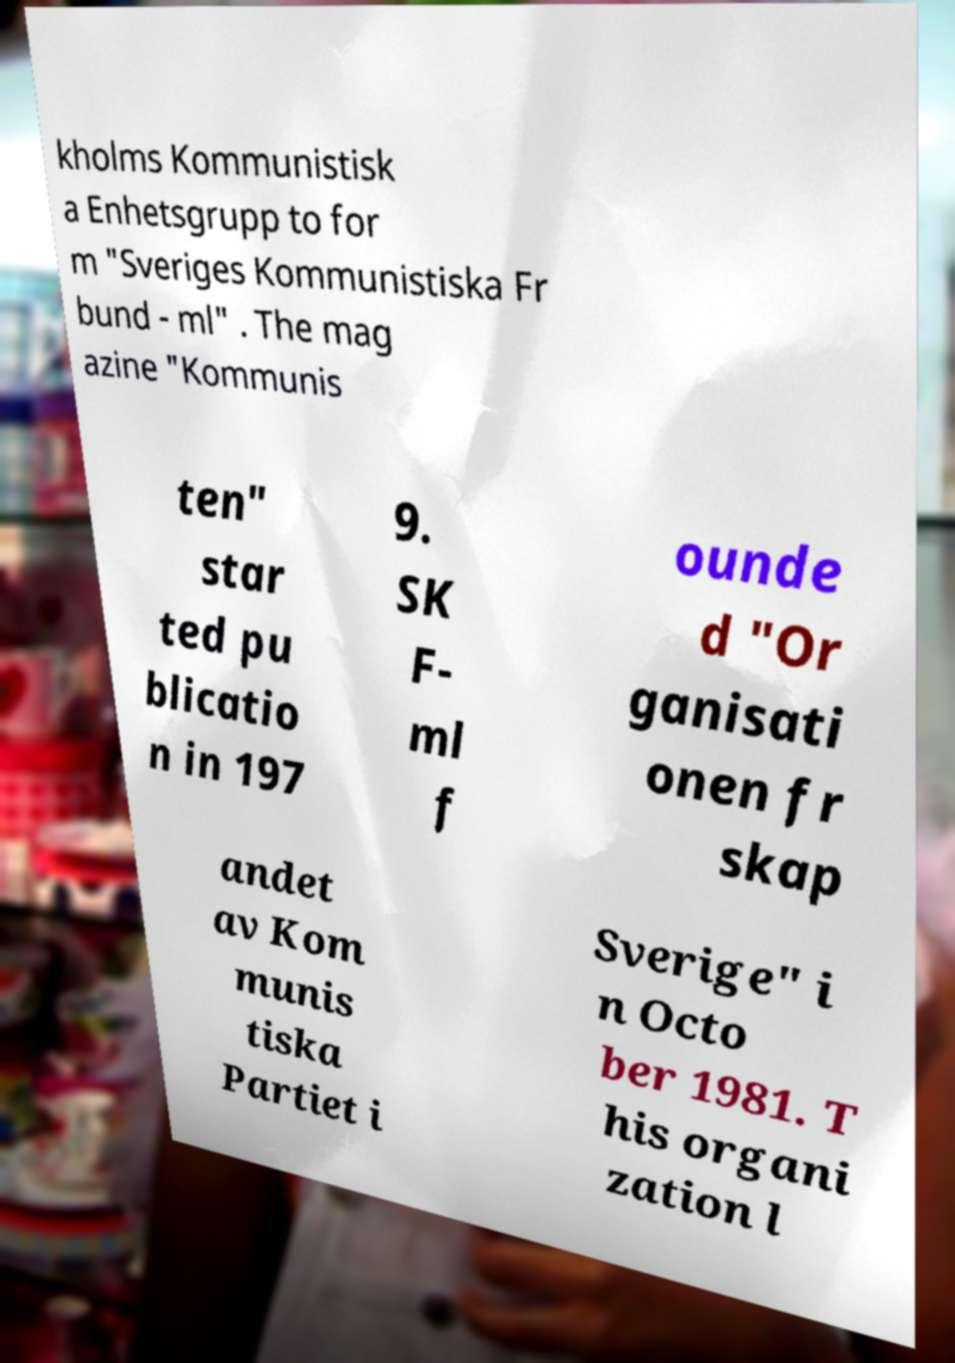Please identify and transcribe the text found in this image. kholms Kommunistisk a Enhetsgrupp to for m "Sveriges Kommunistiska Fr bund - ml" . The mag azine "Kommunis ten" star ted pu blicatio n in 197 9. SK F- ml f ounde d "Or ganisati onen fr skap andet av Kom munis tiska Partiet i Sverige" i n Octo ber 1981. T his organi zation l 